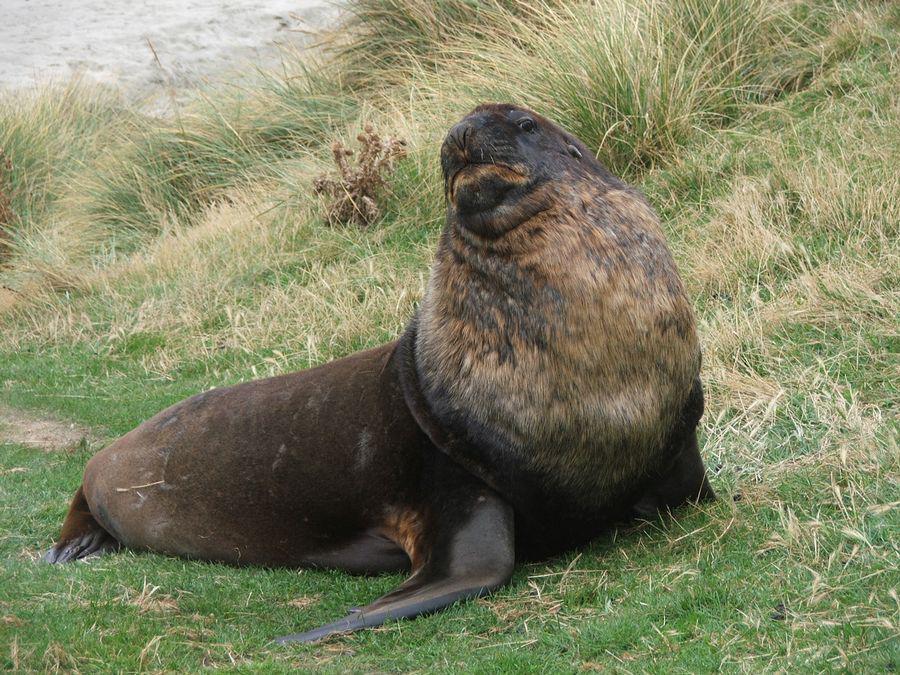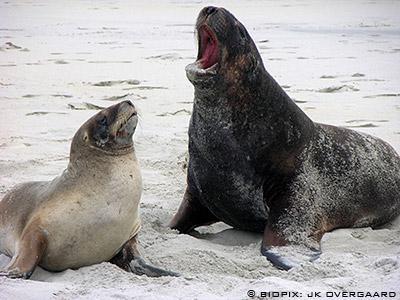The first image is the image on the left, the second image is the image on the right. Assess this claim about the two images: "There are four sea lions in the image pair.". Correct or not? Answer yes or no. No. The first image is the image on the left, the second image is the image on the right. Considering the images on both sides, is "The right image contains exactly two seals." valid? Answer yes or no. Yes. 